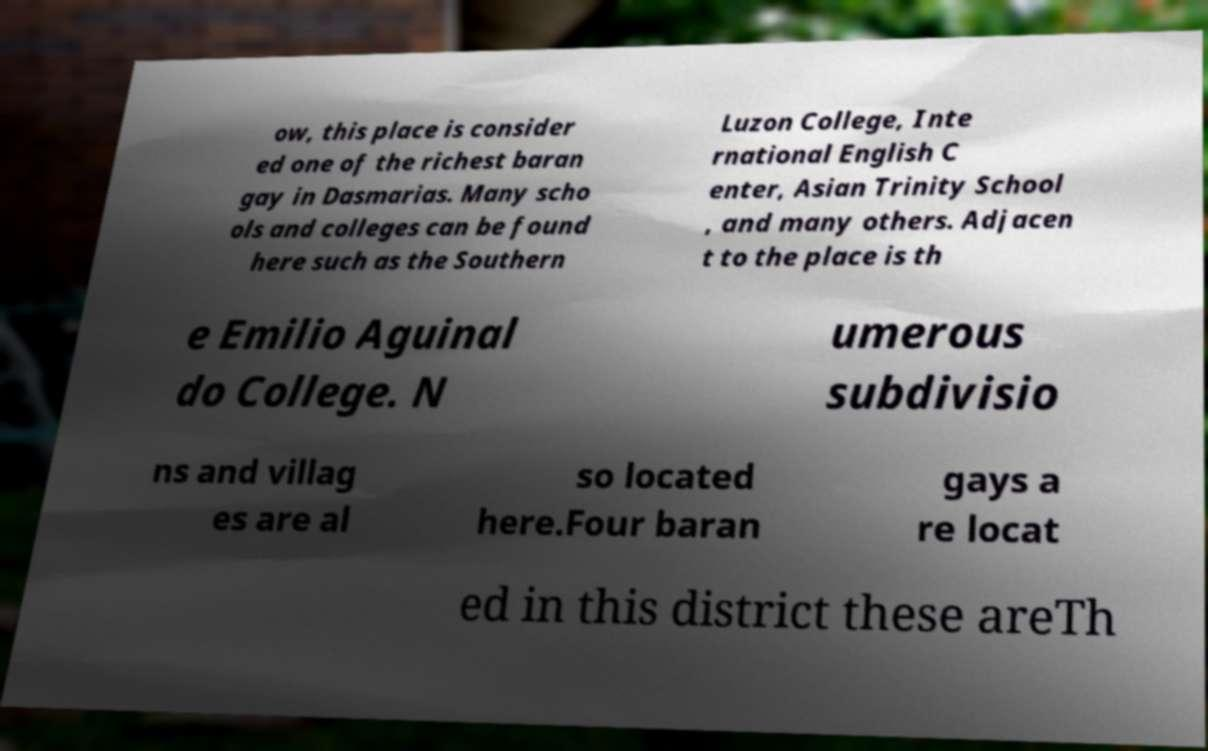Can you accurately transcribe the text from the provided image for me? ow, this place is consider ed one of the richest baran gay in Dasmarias. Many scho ols and colleges can be found here such as the Southern Luzon College, Inte rnational English C enter, Asian Trinity School , and many others. Adjacen t to the place is th e Emilio Aguinal do College. N umerous subdivisio ns and villag es are al so located here.Four baran gays a re locat ed in this district these areTh 